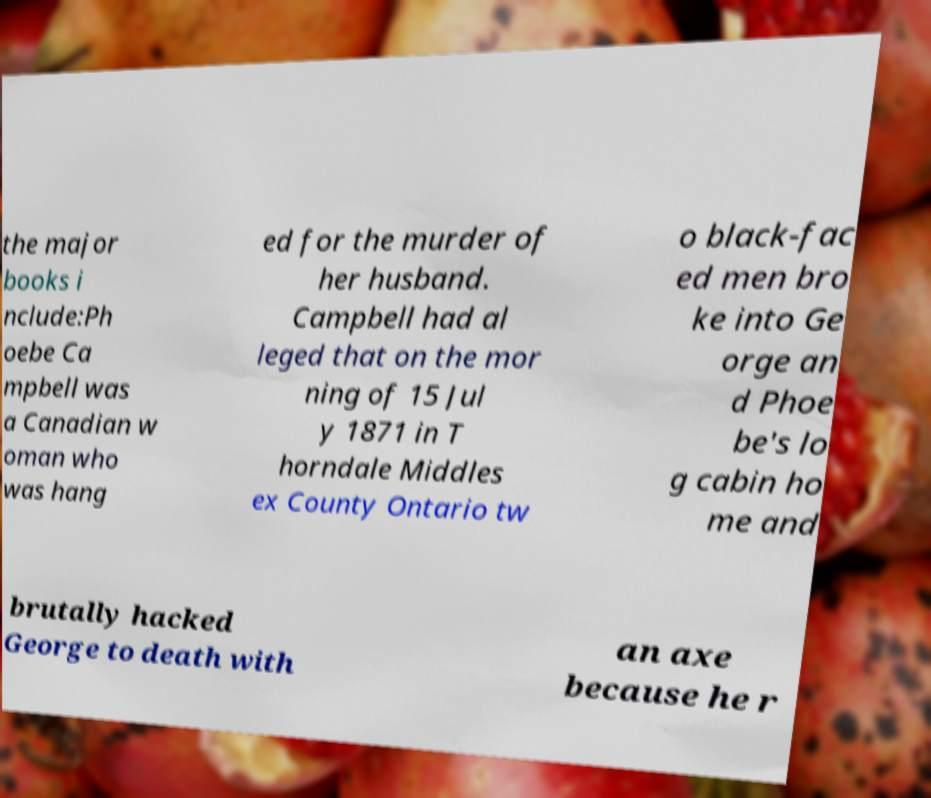Could you extract and type out the text from this image? the major books i nclude:Ph oebe Ca mpbell was a Canadian w oman who was hang ed for the murder of her husband. Campbell had al leged that on the mor ning of 15 Jul y 1871 in T horndale Middles ex County Ontario tw o black-fac ed men bro ke into Ge orge an d Phoe be's lo g cabin ho me and brutally hacked George to death with an axe because he r 